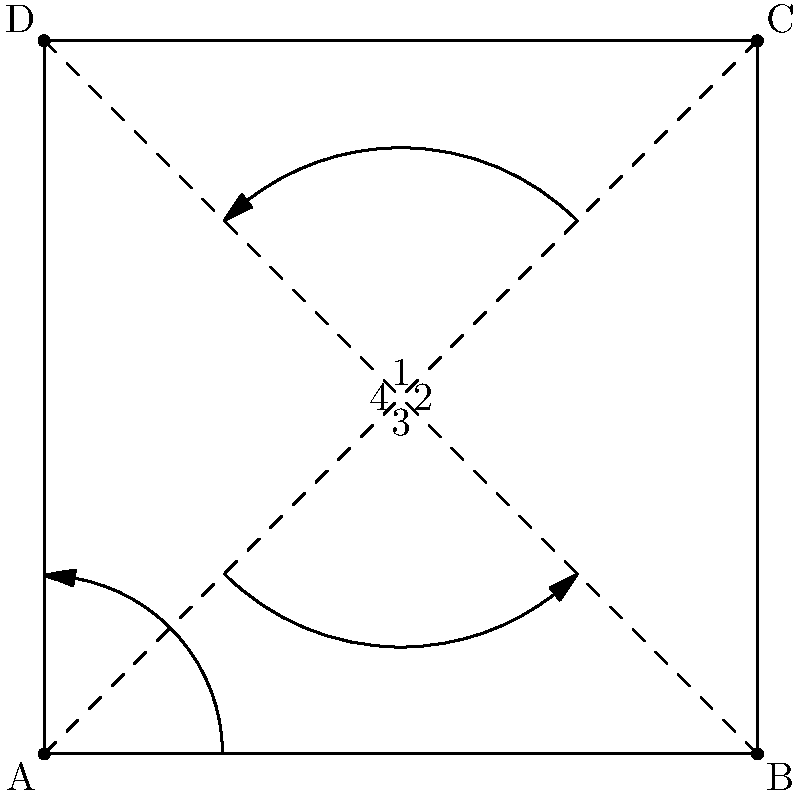Consider the symmetries of a square ABCD shown in the figure. How many elements are in the symmetry group of the square, and what types of symmetries are represented? Explain how this relates to the concept of group theory and its application in educational program design for children with incarcerated parents. To answer this question, let's break it down step-by-step:

1. Symmetries of a square:
   a) Rotations: 0°, 90°, 180°, 270° (4 rotations)
   b) Reflections: 2 diagonal reflections, 2 midline reflections (4 reflections)

2. Total number of symmetries:
   4 rotations + 4 reflections = 8 elements in the symmetry group

3. Group theory concept:
   The symmetries of a square form a group called the dihedral group D4, which has 8 elements.

4. Properties of the group:
   a) Closure: Combining any two symmetries results in another symmetry of the square.
   b) Associativity: The order of applying multiple symmetries doesn't matter.
   c) Identity: The 0° rotation (doing nothing) is the identity element.
   d) Inverse: Each symmetry has an inverse that undoes its effect.

5. Application in educational program design:
   a) Teaching group theory concepts through familiar shapes can make abstract ideas more concrete for children.
   b) Using symmetry groups can help develop spatial reasoning and pattern recognition skills.
   c) The concept of group structure can be used as a metaphor for family dynamics and relationships, helping children understand their situation better.
   d) Activities involving symmetry groups can promote problem-solving skills and critical thinking.
   e) Understanding group theory can lead to discussions about order, structure, and rules in society, which is relevant for children with incarcerated parents.

By incorporating these concepts into educational programs, teachers can help children with incarcerated parents develop mathematical skills while also addressing their unique emotional and social needs.
Answer: 8 elements: 4 rotations and 4 reflections, forming the dihedral group D4. 